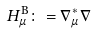<formula> <loc_0><loc_0><loc_500><loc_500>H _ { \mu } ^ { \mathrm B } \colon = \nabla _ { \mu } ^ { * } \nabla</formula> 